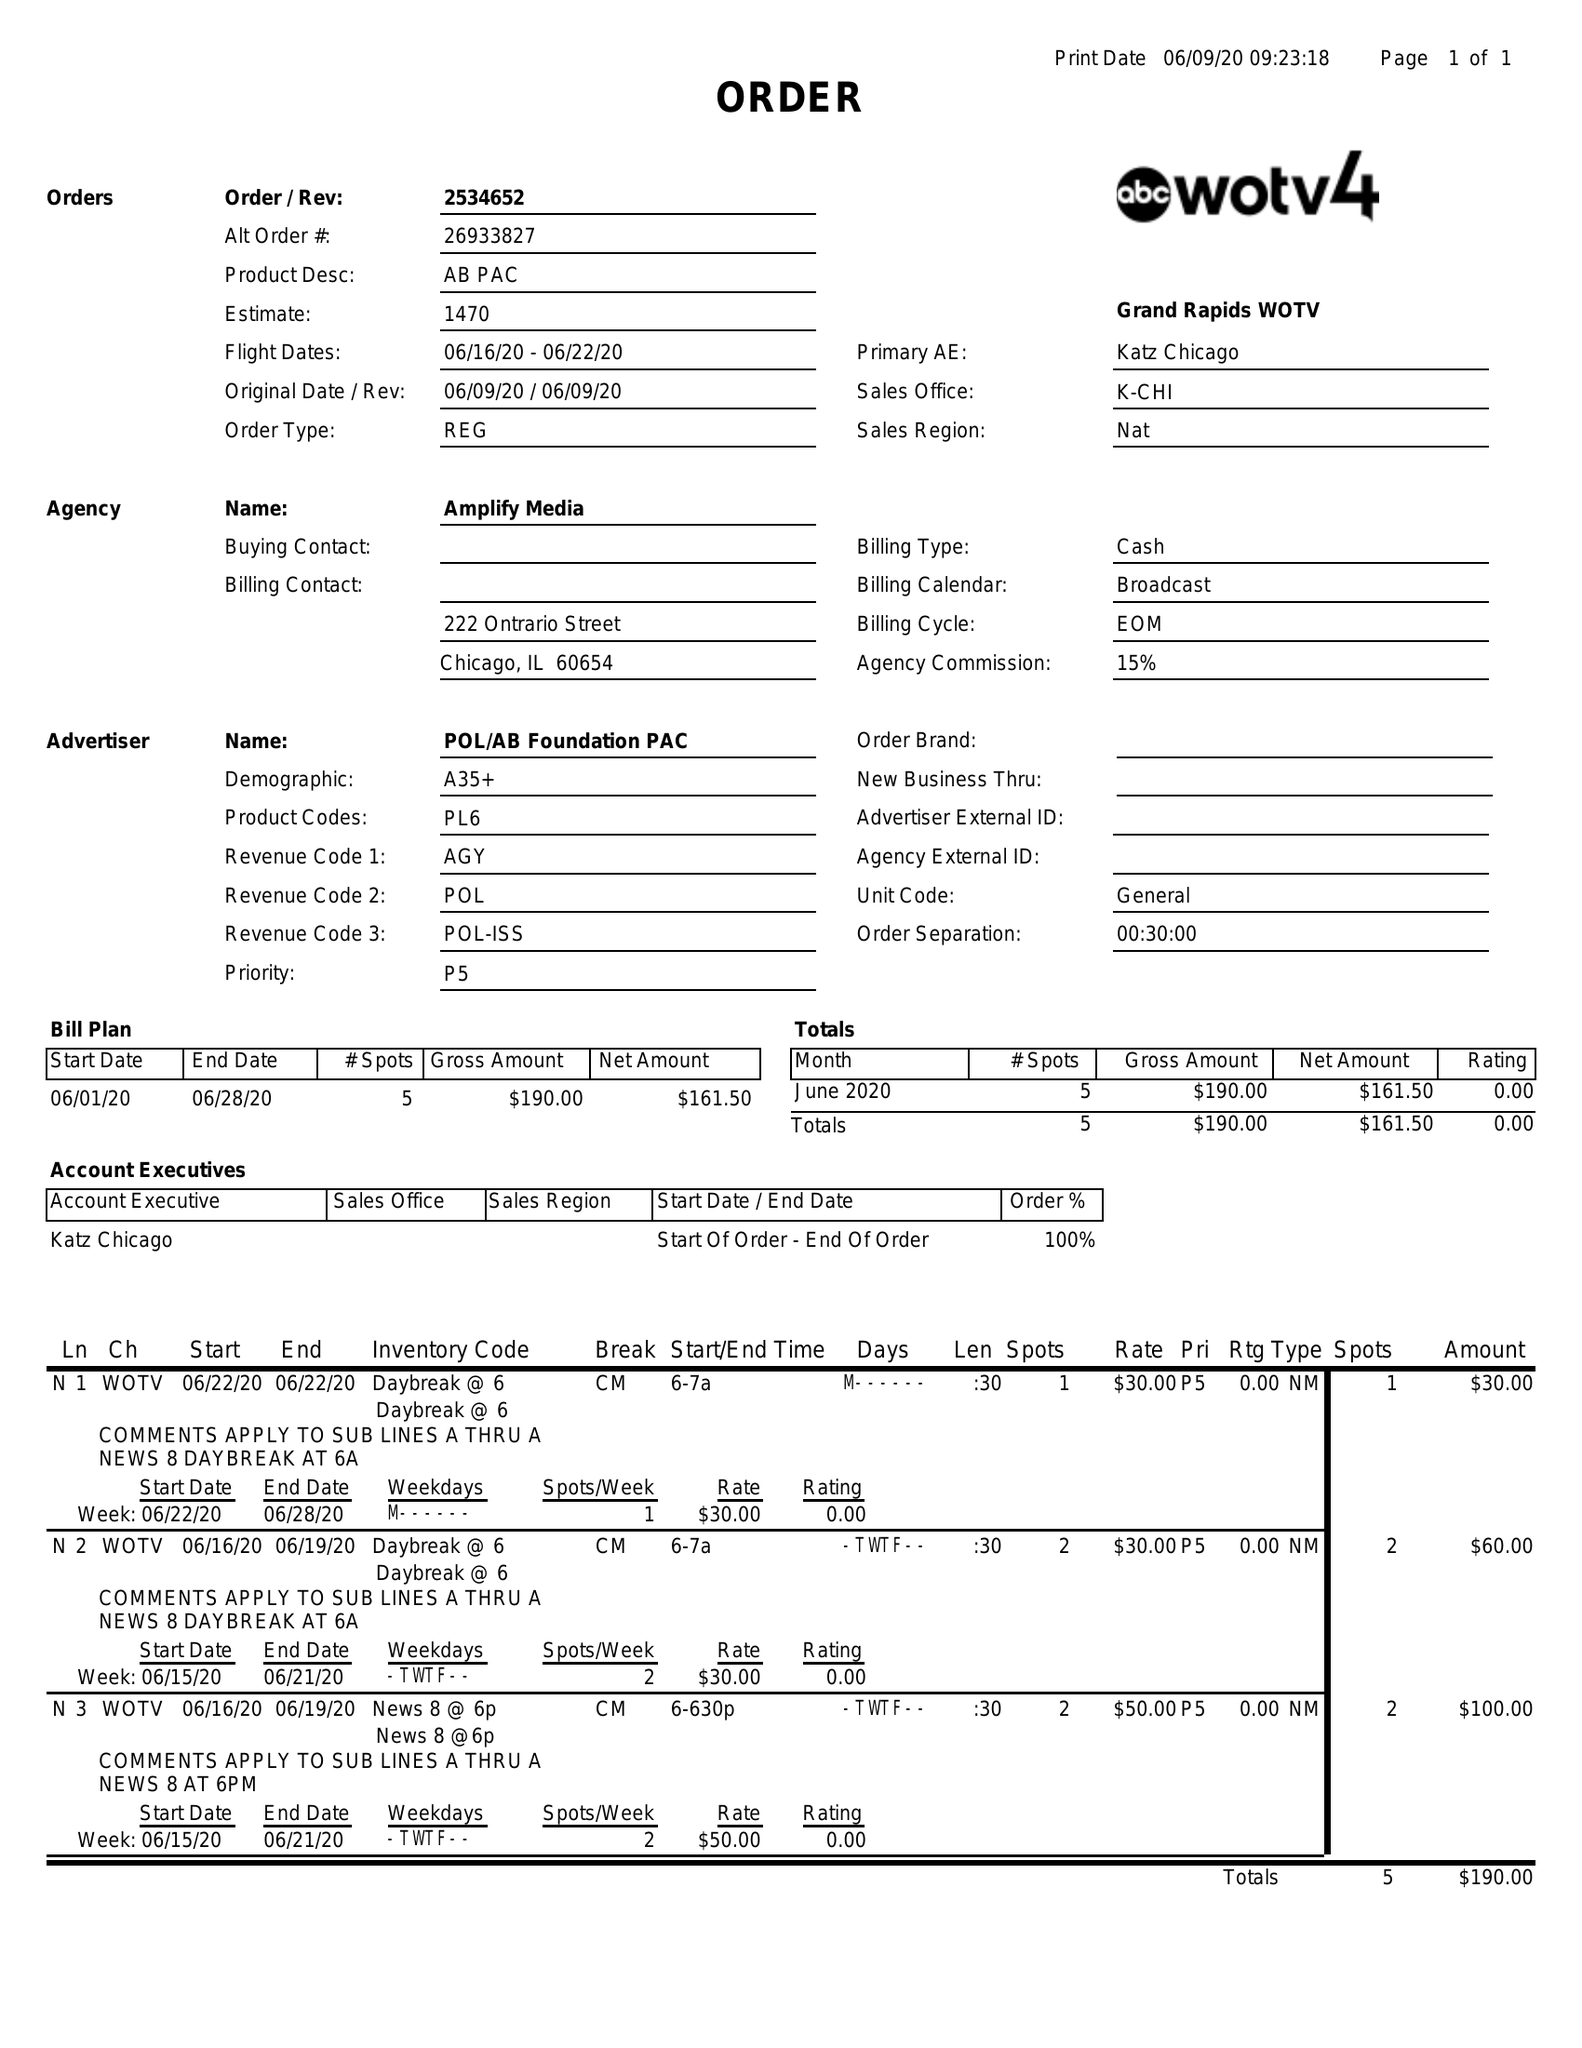What is the value for the advertiser?
Answer the question using a single word or phrase. POL/ABFOUNDATIONPAC 